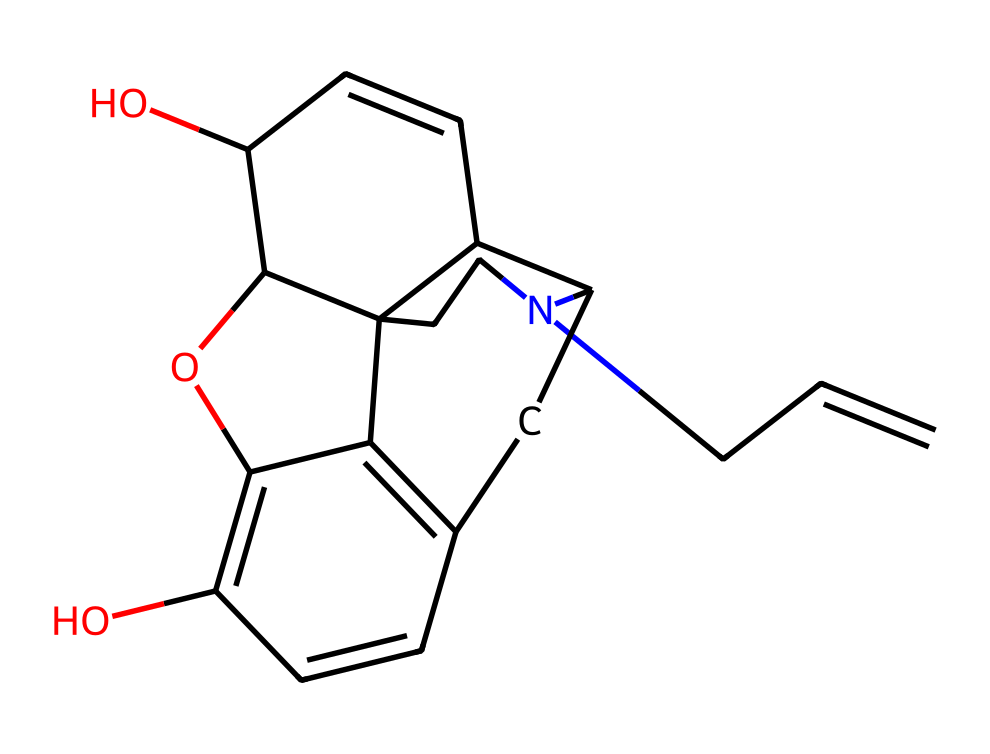What is the molecular formula of naloxone? To find the molecular formula, count all the carbon (C), hydrogen (H), nitrogen (N), and oxygen (O) atoms in the SMILES representation. This representation shows 17 carbons, 19 hydrogens, 1 nitrogen, and 2 oxygens. Thus, the molecular formula is C17H19N2O2.
Answer: C17H19N2O2 How many rings are present in the naloxone structure? Examining the SMILES structure reveals the presence of multiple ring structures by identifying the numbers that indicate cyclic connections. In naloxone, there are four ring structures evident in the depiction.
Answer: 4 What type of functional groups are present in naloxone? By analyzing the structure for specific arrangements of atoms, the hydroxyl (-OH) groups are identified, indicating the presence of alcohol functional groups, which are seen at two locations in the molecule.
Answer: alcohol Which part of naloxone contributes to its pharmacological activity? Analyzing the structural components, the nitrogen atom in the cyclic amine part plays a crucial role in receptor interaction, specifically with opioid receptors, making it key for its action as an overdose reversal agent.
Answer: nitrogen What is the significance of the stereochemistry in naloxone? The arrangement of atoms in three-dimensional space is pivotal for naloxone's ability to bind selectively to opioid receptors. The particular stereochemistry allows it to act competitively against opioids, highlighting its therapeutic effect in overdose scenarios.
Answer: binding selectivity Why is naloxone's structure classified as a semi-synthetic opioid? By examining its structure, naloxone is derived from thebaine, a natural opiate. However, modifications have been made to enhance its profile for opioid receptor activity, classifying it as a semi-synthetic derivative.
Answer: semi-synthetic 